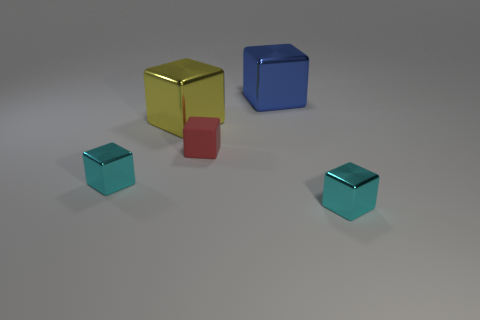Subtract 2 blocks. How many blocks are left? 3 Subtract all big blue shiny cubes. How many cubes are left? 4 Subtract all red blocks. How many blocks are left? 4 Subtract all purple blocks. Subtract all red spheres. How many blocks are left? 5 Add 5 metal blocks. How many objects exist? 10 Subtract all large gray matte cylinders. Subtract all blue blocks. How many objects are left? 4 Add 3 large objects. How many large objects are left? 5 Add 3 big metallic balls. How many big metallic balls exist? 3 Subtract 0 brown cylinders. How many objects are left? 5 